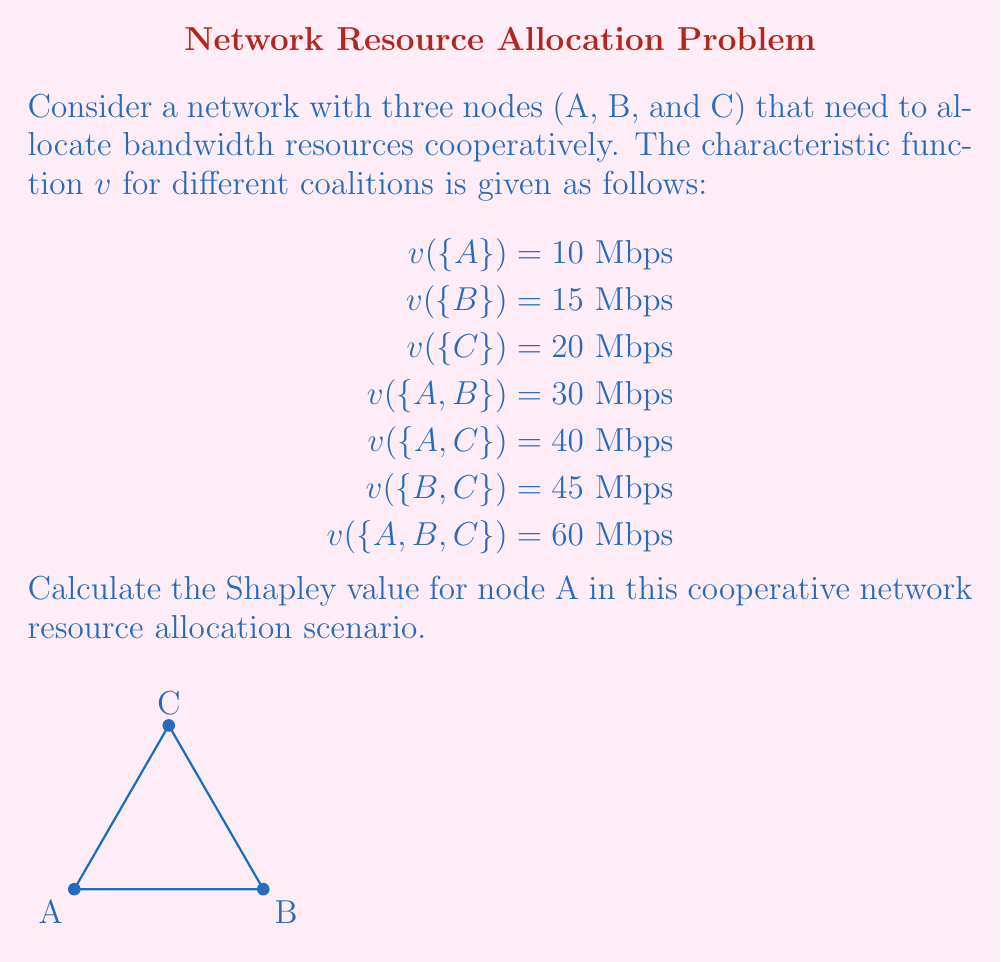Can you answer this question? To calculate the Shapley value for node A, we need to determine its marginal contribution in all possible coalition orders and then take the average. There are 3! = 6 possible orders.

1) First, list all possible orders and A's marginal contribution in each:

   ABC: $v(\{A\}) - v(\{\}) = 10$
   ACB: $v(\{A\}) - v(\{\}) = 10$
   BAC: $v(\{A,B\}) - v(\{B\}) = 30 - 15 = 15$
   BCA: $v(\{A,B,C\}) - v(\{B,C\}) = 60 - 45 = 15$
   CAB: $v(\{A,C\}) - v(\{C\}) = 40 - 20 = 20$
   CBA: $v(\{A,B,C\}) - v(\{B,C\}) = 60 - 45 = 15$

2) Calculate the Shapley value by taking the average of these marginal contributions:

   $$\phi_A = \frac{1}{6}(10 + 10 + 15 + 15 + 20 + 15) = \frac{85}{6}$$

3) Simplify the fraction:

   $$\phi_A = \frac{85}{6} = 14.1666...$$

Therefore, the Shapley value for node A is approximately 14.17 Mbps.
Answer: $\frac{85}{6}$ Mbps or approximately 14.17 Mbps 